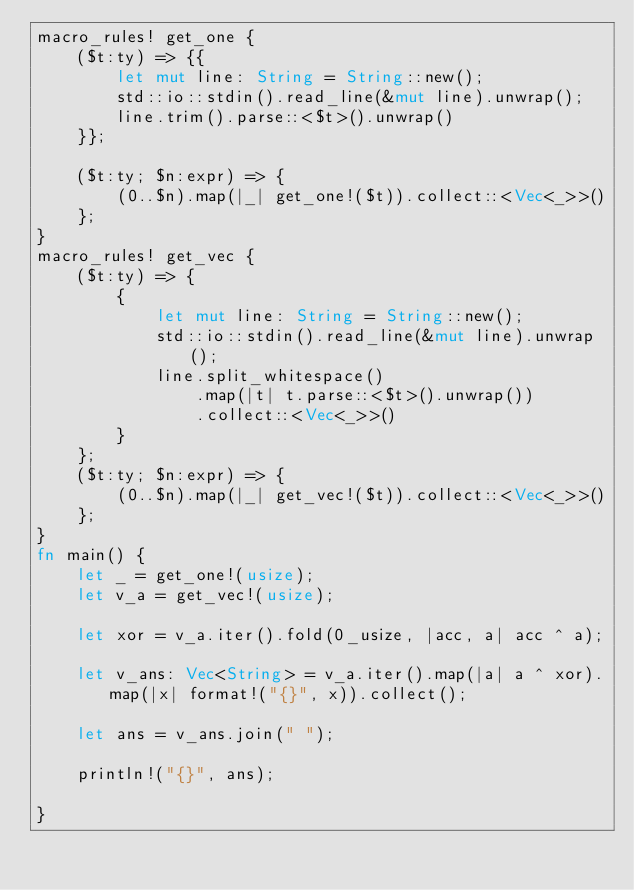Convert code to text. <code><loc_0><loc_0><loc_500><loc_500><_Rust_>macro_rules! get_one {
    ($t:ty) => {{
        let mut line: String = String::new();
        std::io::stdin().read_line(&mut line).unwrap();
        line.trim().parse::<$t>().unwrap()
    }};

    ($t:ty; $n:expr) => {
        (0..$n).map(|_| get_one!($t)).collect::<Vec<_>>()
    };
}
macro_rules! get_vec {
    ($t:ty) => {
        {
            let mut line: String = String::new();
            std::io::stdin().read_line(&mut line).unwrap();
            line.split_whitespace()
                .map(|t| t.parse::<$t>().unwrap())
                .collect::<Vec<_>>()
        }
    };
    ($t:ty; $n:expr) => {
        (0..$n).map(|_| get_vec!($t)).collect::<Vec<_>>()
    };
}
fn main() {
    let _ = get_one!(usize);
    let v_a = get_vec!(usize);

    let xor = v_a.iter().fold(0_usize, |acc, a| acc ^ a);

    let v_ans: Vec<String> = v_a.iter().map(|a| a ^ xor).map(|x| format!("{}", x)).collect();

    let ans = v_ans.join(" ");

    println!("{}", ans);

}
</code> 